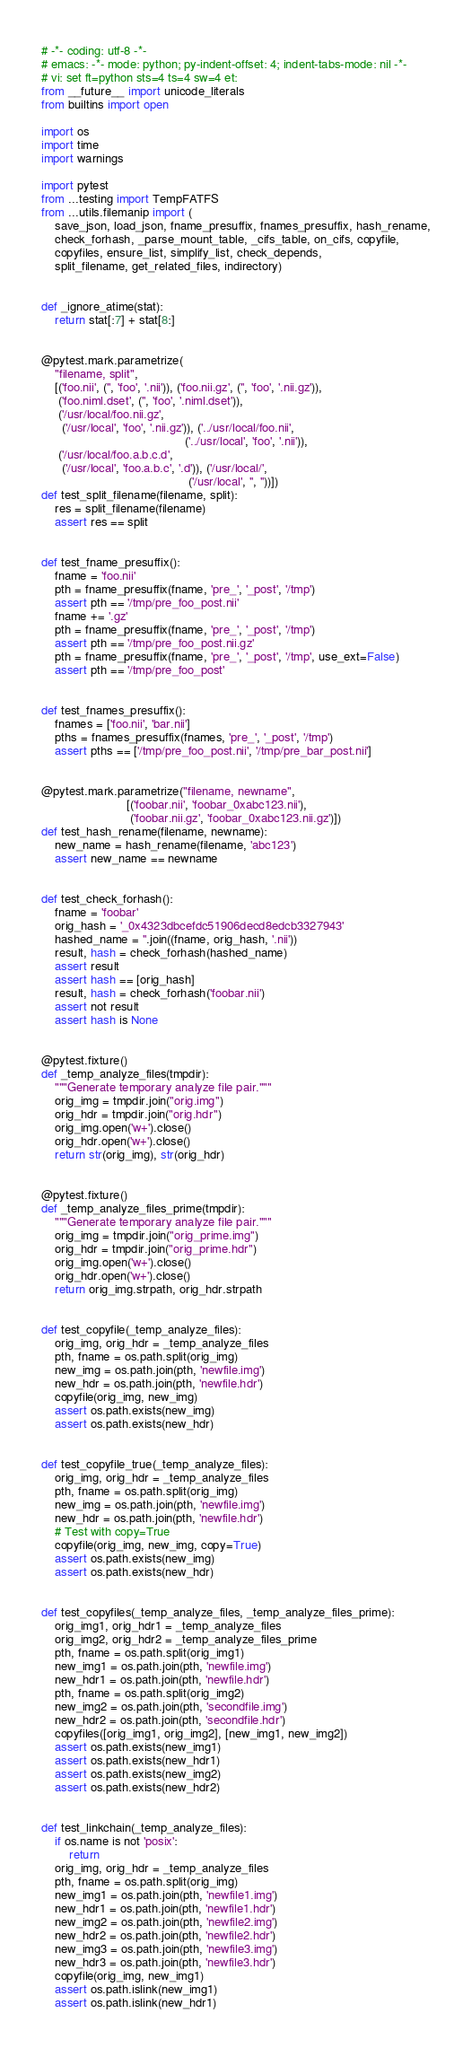<code> <loc_0><loc_0><loc_500><loc_500><_Python_># -*- coding: utf-8 -*-
# emacs: -*- mode: python; py-indent-offset: 4; indent-tabs-mode: nil -*-
# vi: set ft=python sts=4 ts=4 sw=4 et:
from __future__ import unicode_literals
from builtins import open

import os
import time
import warnings

import pytest
from ...testing import TempFATFS
from ...utils.filemanip import (
    save_json, load_json, fname_presuffix, fnames_presuffix, hash_rename,
    check_forhash, _parse_mount_table, _cifs_table, on_cifs, copyfile,
    copyfiles, ensure_list, simplify_list, check_depends,
    split_filename, get_related_files, indirectory)


def _ignore_atime(stat):
    return stat[:7] + stat[8:]


@pytest.mark.parametrize(
    "filename, split",
    [('foo.nii', ('', 'foo', '.nii')), ('foo.nii.gz', ('', 'foo', '.nii.gz')),
     ('foo.niml.dset', ('', 'foo', '.niml.dset')),
     ('/usr/local/foo.nii.gz',
      ('/usr/local', 'foo', '.nii.gz')), ('../usr/local/foo.nii',
                                          ('../usr/local', 'foo', '.nii')),
     ('/usr/local/foo.a.b.c.d',
      ('/usr/local', 'foo.a.b.c', '.d')), ('/usr/local/',
                                           ('/usr/local', '', ''))])
def test_split_filename(filename, split):
    res = split_filename(filename)
    assert res == split


def test_fname_presuffix():
    fname = 'foo.nii'
    pth = fname_presuffix(fname, 'pre_', '_post', '/tmp')
    assert pth == '/tmp/pre_foo_post.nii'
    fname += '.gz'
    pth = fname_presuffix(fname, 'pre_', '_post', '/tmp')
    assert pth == '/tmp/pre_foo_post.nii.gz'
    pth = fname_presuffix(fname, 'pre_', '_post', '/tmp', use_ext=False)
    assert pth == '/tmp/pre_foo_post'


def test_fnames_presuffix():
    fnames = ['foo.nii', 'bar.nii']
    pths = fnames_presuffix(fnames, 'pre_', '_post', '/tmp')
    assert pths == ['/tmp/pre_foo_post.nii', '/tmp/pre_bar_post.nii']


@pytest.mark.parametrize("filename, newname",
                         [('foobar.nii', 'foobar_0xabc123.nii'),
                          ('foobar.nii.gz', 'foobar_0xabc123.nii.gz')])
def test_hash_rename(filename, newname):
    new_name = hash_rename(filename, 'abc123')
    assert new_name == newname


def test_check_forhash():
    fname = 'foobar'
    orig_hash = '_0x4323dbcefdc51906decd8edcb3327943'
    hashed_name = ''.join((fname, orig_hash, '.nii'))
    result, hash = check_forhash(hashed_name)
    assert result
    assert hash == [orig_hash]
    result, hash = check_forhash('foobar.nii')
    assert not result
    assert hash is None


@pytest.fixture()
def _temp_analyze_files(tmpdir):
    """Generate temporary analyze file pair."""
    orig_img = tmpdir.join("orig.img")
    orig_hdr = tmpdir.join("orig.hdr")
    orig_img.open('w+').close()
    orig_hdr.open('w+').close()
    return str(orig_img), str(orig_hdr)


@pytest.fixture()
def _temp_analyze_files_prime(tmpdir):
    """Generate temporary analyze file pair."""
    orig_img = tmpdir.join("orig_prime.img")
    orig_hdr = tmpdir.join("orig_prime.hdr")
    orig_img.open('w+').close()
    orig_hdr.open('w+').close()
    return orig_img.strpath, orig_hdr.strpath


def test_copyfile(_temp_analyze_files):
    orig_img, orig_hdr = _temp_analyze_files
    pth, fname = os.path.split(orig_img)
    new_img = os.path.join(pth, 'newfile.img')
    new_hdr = os.path.join(pth, 'newfile.hdr')
    copyfile(orig_img, new_img)
    assert os.path.exists(new_img)
    assert os.path.exists(new_hdr)


def test_copyfile_true(_temp_analyze_files):
    orig_img, orig_hdr = _temp_analyze_files
    pth, fname = os.path.split(orig_img)
    new_img = os.path.join(pth, 'newfile.img')
    new_hdr = os.path.join(pth, 'newfile.hdr')
    # Test with copy=True
    copyfile(orig_img, new_img, copy=True)
    assert os.path.exists(new_img)
    assert os.path.exists(new_hdr)


def test_copyfiles(_temp_analyze_files, _temp_analyze_files_prime):
    orig_img1, orig_hdr1 = _temp_analyze_files
    orig_img2, orig_hdr2 = _temp_analyze_files_prime
    pth, fname = os.path.split(orig_img1)
    new_img1 = os.path.join(pth, 'newfile.img')
    new_hdr1 = os.path.join(pth, 'newfile.hdr')
    pth, fname = os.path.split(orig_img2)
    new_img2 = os.path.join(pth, 'secondfile.img')
    new_hdr2 = os.path.join(pth, 'secondfile.hdr')
    copyfiles([orig_img1, orig_img2], [new_img1, new_img2])
    assert os.path.exists(new_img1)
    assert os.path.exists(new_hdr1)
    assert os.path.exists(new_img2)
    assert os.path.exists(new_hdr2)


def test_linkchain(_temp_analyze_files):
    if os.name is not 'posix':
        return
    orig_img, orig_hdr = _temp_analyze_files
    pth, fname = os.path.split(orig_img)
    new_img1 = os.path.join(pth, 'newfile1.img')
    new_hdr1 = os.path.join(pth, 'newfile1.hdr')
    new_img2 = os.path.join(pth, 'newfile2.img')
    new_hdr2 = os.path.join(pth, 'newfile2.hdr')
    new_img3 = os.path.join(pth, 'newfile3.img')
    new_hdr3 = os.path.join(pth, 'newfile3.hdr')
    copyfile(orig_img, new_img1)
    assert os.path.islink(new_img1)
    assert os.path.islink(new_hdr1)</code> 